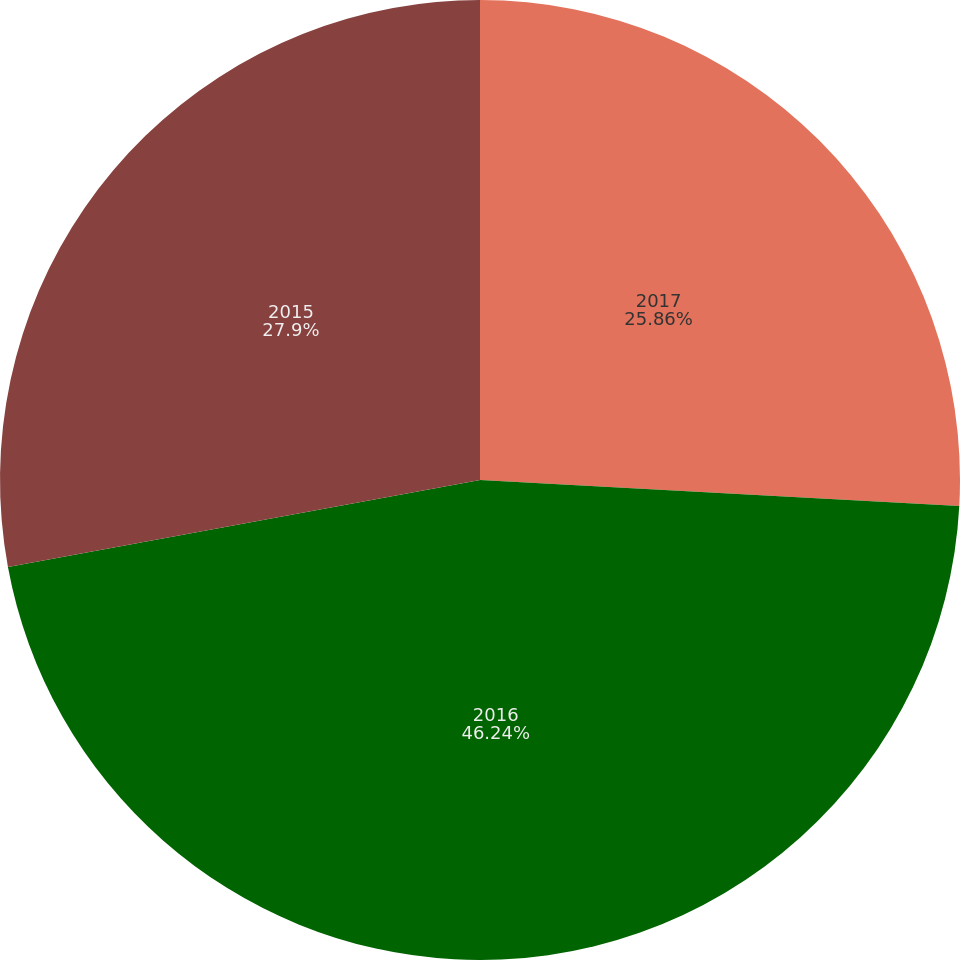<chart> <loc_0><loc_0><loc_500><loc_500><pie_chart><fcel>2017<fcel>2016<fcel>2015<nl><fcel>25.86%<fcel>46.24%<fcel>27.9%<nl></chart> 